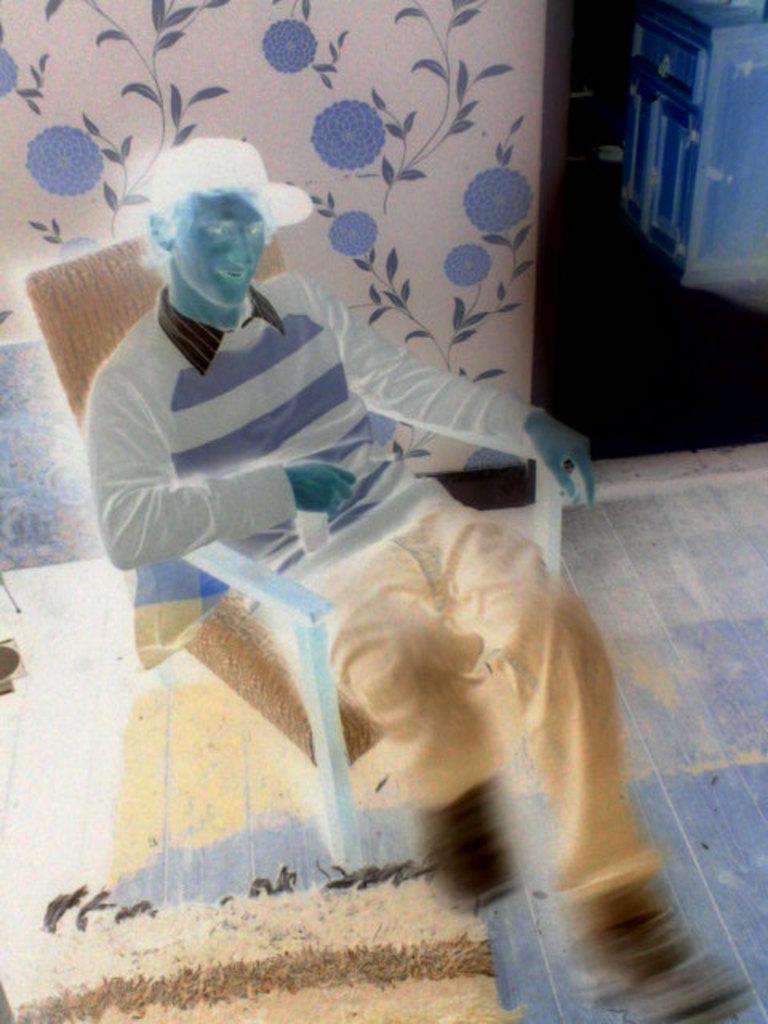How would you summarize this image in a sentence or two? There is a negative image. At the bottom left of the image there is a mat. In the middle of the floor there is a man sitting on the chair. Behind him there is a wall with paintings of flowers and leaves. At the top right of the image there is a cupboard.  